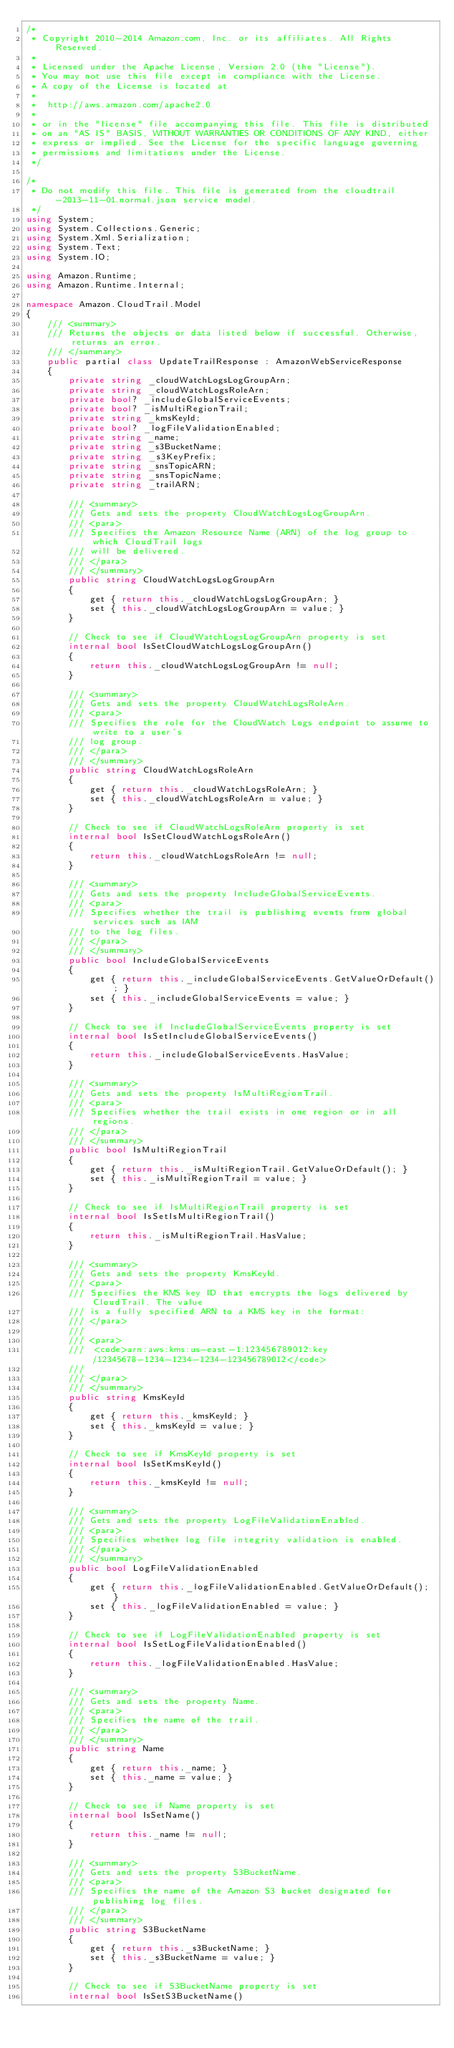Convert code to text. <code><loc_0><loc_0><loc_500><loc_500><_C#_>/*
 * Copyright 2010-2014 Amazon.com, Inc. or its affiliates. All Rights Reserved.
 * 
 * Licensed under the Apache License, Version 2.0 (the "License").
 * You may not use this file except in compliance with the License.
 * A copy of the License is located at
 * 
 *  http://aws.amazon.com/apache2.0
 * 
 * or in the "license" file accompanying this file. This file is distributed
 * on an "AS IS" BASIS, WITHOUT WARRANTIES OR CONDITIONS OF ANY KIND, either
 * express or implied. See the License for the specific language governing
 * permissions and limitations under the License.
 */

/*
 * Do not modify this file. This file is generated from the cloudtrail-2013-11-01.normal.json service model.
 */
using System;
using System.Collections.Generic;
using System.Xml.Serialization;
using System.Text;
using System.IO;

using Amazon.Runtime;
using Amazon.Runtime.Internal;

namespace Amazon.CloudTrail.Model
{
    /// <summary>
    /// Returns the objects or data listed below if successful. Otherwise, returns an error.
    /// </summary>
    public partial class UpdateTrailResponse : AmazonWebServiceResponse
    {
        private string _cloudWatchLogsLogGroupArn;
        private string _cloudWatchLogsRoleArn;
        private bool? _includeGlobalServiceEvents;
        private bool? _isMultiRegionTrail;
        private string _kmsKeyId;
        private bool? _logFileValidationEnabled;
        private string _name;
        private string _s3BucketName;
        private string _s3KeyPrefix;
        private string _snsTopicARN;
        private string _snsTopicName;
        private string _trailARN;

        /// <summary>
        /// Gets and sets the property CloudWatchLogsLogGroupArn. 
        /// <para>
        /// Specifies the Amazon Resource Name (ARN) of the log group to which CloudTrail logs
        /// will be delivered.
        /// </para>
        /// </summary>
        public string CloudWatchLogsLogGroupArn
        {
            get { return this._cloudWatchLogsLogGroupArn; }
            set { this._cloudWatchLogsLogGroupArn = value; }
        }

        // Check to see if CloudWatchLogsLogGroupArn property is set
        internal bool IsSetCloudWatchLogsLogGroupArn()
        {
            return this._cloudWatchLogsLogGroupArn != null;
        }

        /// <summary>
        /// Gets and sets the property CloudWatchLogsRoleArn. 
        /// <para>
        /// Specifies the role for the CloudWatch Logs endpoint to assume to write to a user's
        /// log group.
        /// </para>
        /// </summary>
        public string CloudWatchLogsRoleArn
        {
            get { return this._cloudWatchLogsRoleArn; }
            set { this._cloudWatchLogsRoleArn = value; }
        }

        // Check to see if CloudWatchLogsRoleArn property is set
        internal bool IsSetCloudWatchLogsRoleArn()
        {
            return this._cloudWatchLogsRoleArn != null;
        }

        /// <summary>
        /// Gets and sets the property IncludeGlobalServiceEvents. 
        /// <para>
        /// Specifies whether the trail is publishing events from global services such as IAM
        /// to the log files.
        /// </para>
        /// </summary>
        public bool IncludeGlobalServiceEvents
        {
            get { return this._includeGlobalServiceEvents.GetValueOrDefault(); }
            set { this._includeGlobalServiceEvents = value; }
        }

        // Check to see if IncludeGlobalServiceEvents property is set
        internal bool IsSetIncludeGlobalServiceEvents()
        {
            return this._includeGlobalServiceEvents.HasValue; 
        }

        /// <summary>
        /// Gets and sets the property IsMultiRegionTrail. 
        /// <para>
        /// Specifies whether the trail exists in one region or in all regions.
        /// </para>
        /// </summary>
        public bool IsMultiRegionTrail
        {
            get { return this._isMultiRegionTrail.GetValueOrDefault(); }
            set { this._isMultiRegionTrail = value; }
        }

        // Check to see if IsMultiRegionTrail property is set
        internal bool IsSetIsMultiRegionTrail()
        {
            return this._isMultiRegionTrail.HasValue; 
        }

        /// <summary>
        /// Gets and sets the property KmsKeyId. 
        /// <para>
        /// Specifies the KMS key ID that encrypts the logs delivered by CloudTrail. The value
        /// is a fully specified ARN to a KMS key in the format:
        /// </para>
        ///  
        /// <para>
        ///  <code>arn:aws:kms:us-east-1:123456789012:key/12345678-1234-1234-1234-123456789012</code>
        /// 
        /// </para>
        /// </summary>
        public string KmsKeyId
        {
            get { return this._kmsKeyId; }
            set { this._kmsKeyId = value; }
        }

        // Check to see if KmsKeyId property is set
        internal bool IsSetKmsKeyId()
        {
            return this._kmsKeyId != null;
        }

        /// <summary>
        /// Gets and sets the property LogFileValidationEnabled. 
        /// <para>
        /// Specifies whether log file integrity validation is enabled.
        /// </para>
        /// </summary>
        public bool LogFileValidationEnabled
        {
            get { return this._logFileValidationEnabled.GetValueOrDefault(); }
            set { this._logFileValidationEnabled = value; }
        }

        // Check to see if LogFileValidationEnabled property is set
        internal bool IsSetLogFileValidationEnabled()
        {
            return this._logFileValidationEnabled.HasValue; 
        }

        /// <summary>
        /// Gets and sets the property Name. 
        /// <para>
        /// Specifies the name of the trail.
        /// </para>
        /// </summary>
        public string Name
        {
            get { return this._name; }
            set { this._name = value; }
        }

        // Check to see if Name property is set
        internal bool IsSetName()
        {
            return this._name != null;
        }

        /// <summary>
        /// Gets and sets the property S3BucketName. 
        /// <para>
        /// Specifies the name of the Amazon S3 bucket designated for publishing log files.
        /// </para>
        /// </summary>
        public string S3BucketName
        {
            get { return this._s3BucketName; }
            set { this._s3BucketName = value; }
        }

        // Check to see if S3BucketName property is set
        internal bool IsSetS3BucketName()</code> 